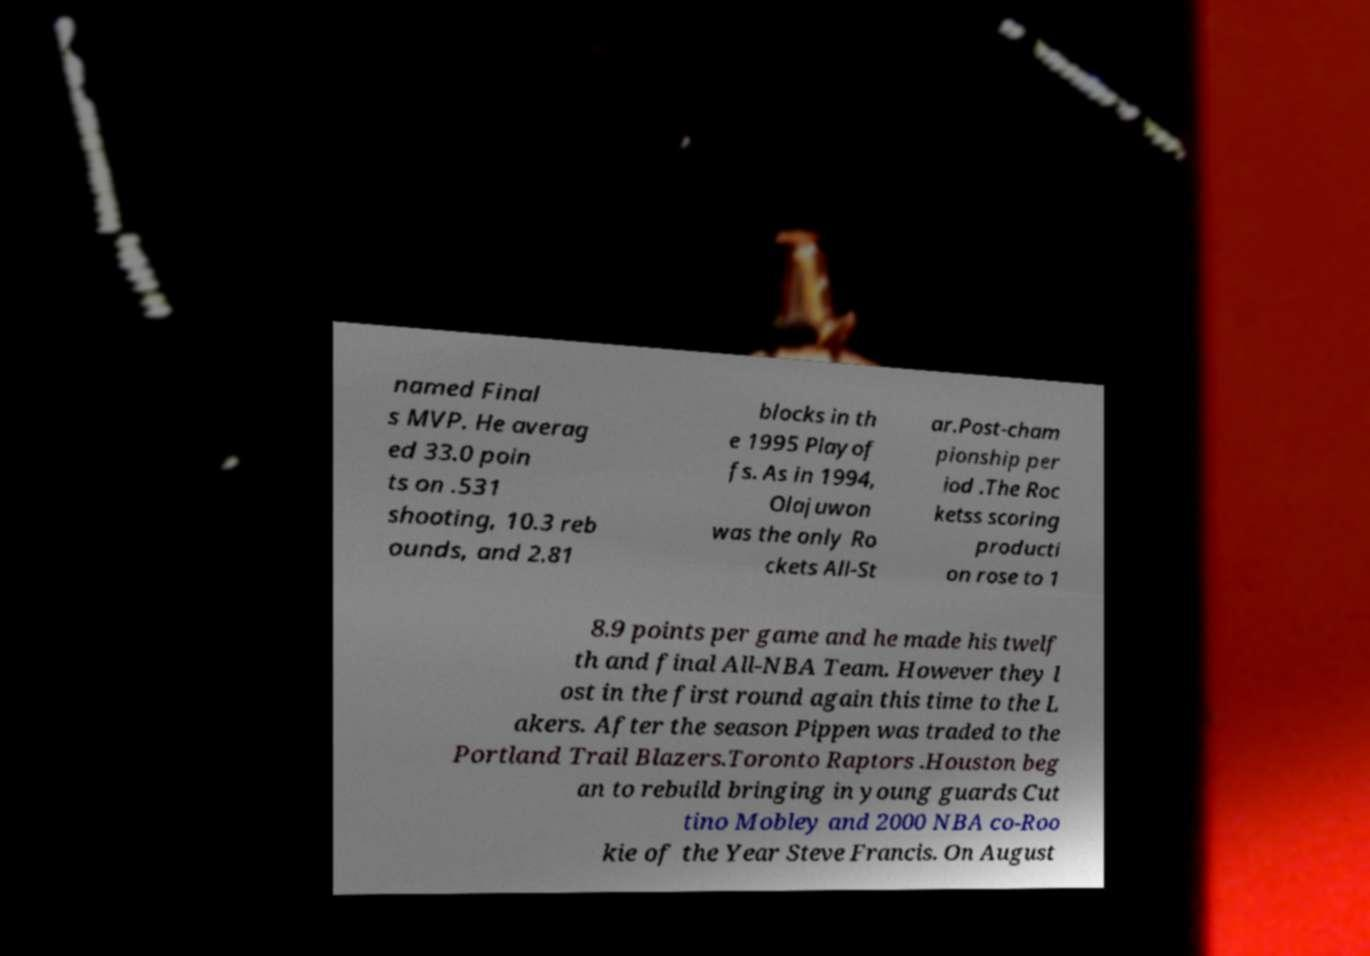Can you read and provide the text displayed in the image?This photo seems to have some interesting text. Can you extract and type it out for me? named Final s MVP. He averag ed 33.0 poin ts on .531 shooting, 10.3 reb ounds, and 2.81 blocks in th e 1995 Playof fs. As in 1994, Olajuwon was the only Ro ckets All-St ar.Post-cham pionship per iod .The Roc ketss scoring producti on rose to 1 8.9 points per game and he made his twelf th and final All-NBA Team. However they l ost in the first round again this time to the L akers. After the season Pippen was traded to the Portland Trail Blazers.Toronto Raptors .Houston beg an to rebuild bringing in young guards Cut tino Mobley and 2000 NBA co-Roo kie of the Year Steve Francis. On August 